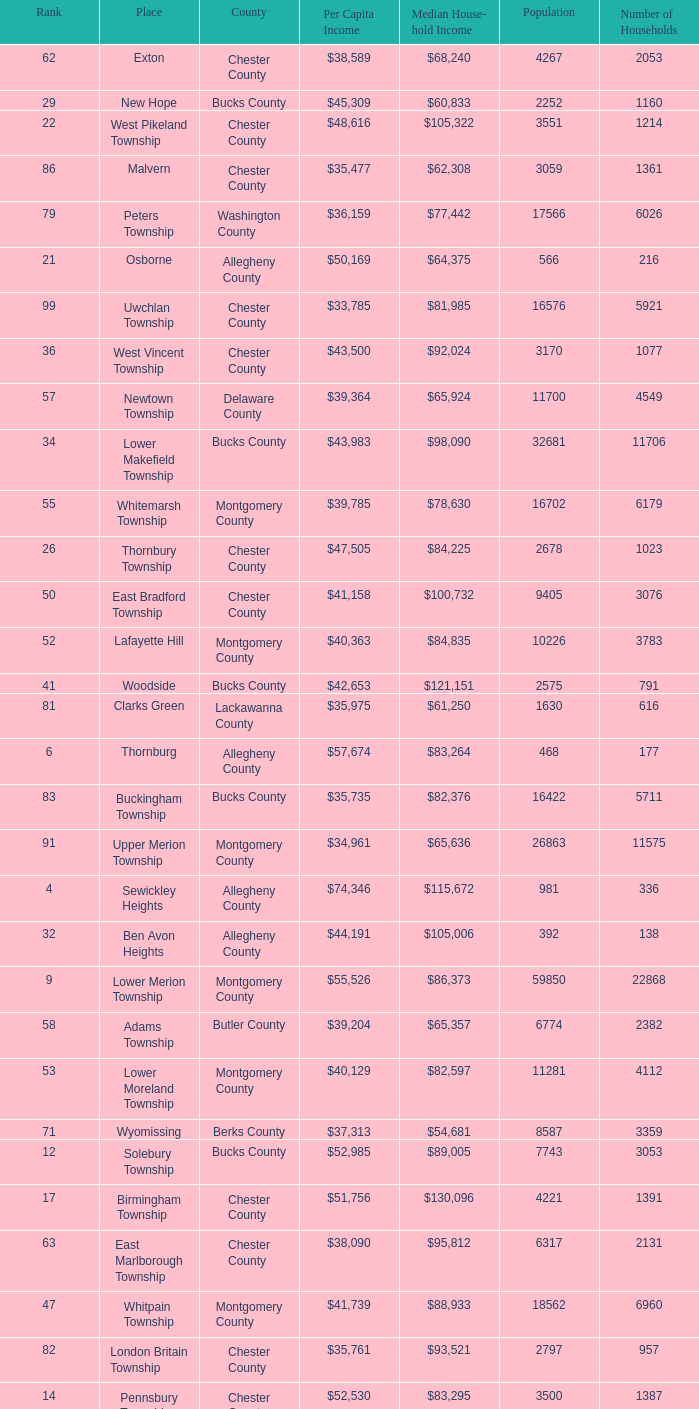What is the per capita income for Fayette County? $42,131. 